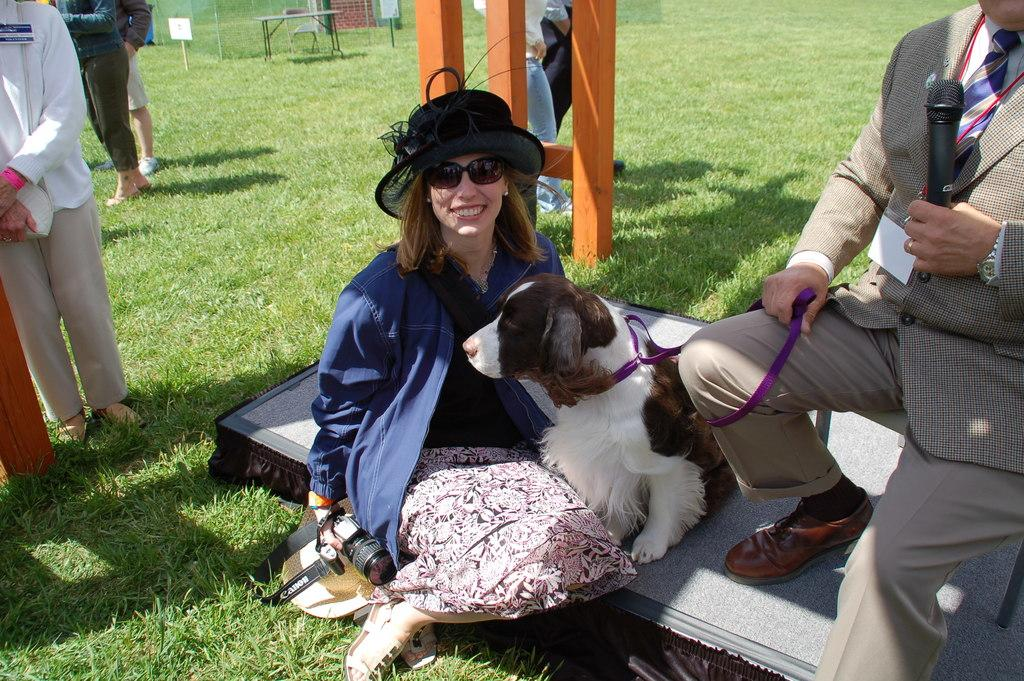Who is present in the image? There is a woman, a dog, and a man in the image. What is the woman doing in the image? The woman is sitting in the image. What is the dog doing in the image? The dog is on a bench in the image. What is the man holding in his hand? The man is holding a mic in his hand. What is the man doing with the dog? The man is holding the dog's belt in the image. What type of coil is visible in the image? There is no coil present in the image. What kind of crack can be seen on the bench where the dog is sitting? There is no crack visible on the bench in the image. 